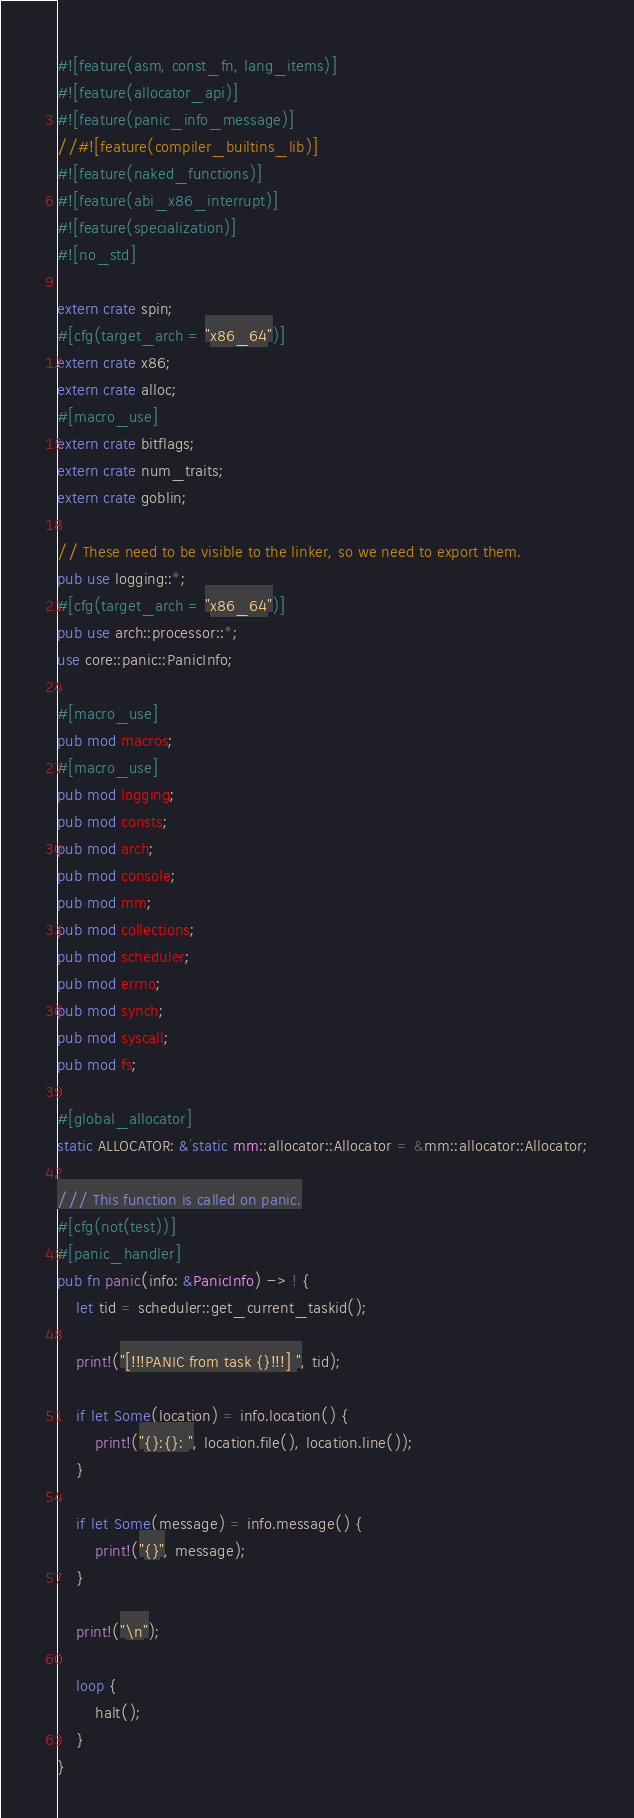<code> <loc_0><loc_0><loc_500><loc_500><_Rust_>#![feature(asm, const_fn, lang_items)]
#![feature(allocator_api)]
#![feature(panic_info_message)]
//#![feature(compiler_builtins_lib)]
#![feature(naked_functions)]
#![feature(abi_x86_interrupt)]
#![feature(specialization)]
#![no_std]

extern crate spin;
#[cfg(target_arch = "x86_64")]
extern crate x86;
extern crate alloc;
#[macro_use]
extern crate bitflags;
extern crate num_traits;
extern crate goblin;

// These need to be visible to the linker, so we need to export them.
pub use logging::*;
#[cfg(target_arch = "x86_64")]
pub use arch::processor::*;
use core::panic::PanicInfo;

#[macro_use]
pub mod macros;
#[macro_use]
pub mod logging;
pub mod consts;
pub mod arch;
pub mod console;
pub mod mm;
pub mod collections;
pub mod scheduler;
pub mod errno;
pub mod synch;
pub mod syscall;
pub mod fs;

#[global_allocator]
static ALLOCATOR: &'static mm::allocator::Allocator = &mm::allocator::Allocator;

/// This function is called on panic.
#[cfg(not(test))]
#[panic_handler]
pub fn panic(info: &PanicInfo) -> ! {
	let tid = scheduler::get_current_taskid();

	print!("[!!!PANIC from task {}!!!] ", tid);

	if let Some(location) = info.location() {
		print!("{}:{}: ", location.file(), location.line());
	}

	if let Some(message) = info.message() {
		print!("{}", message);
	}

	print!("\n");

	loop {
		halt();
	}
}
</code> 